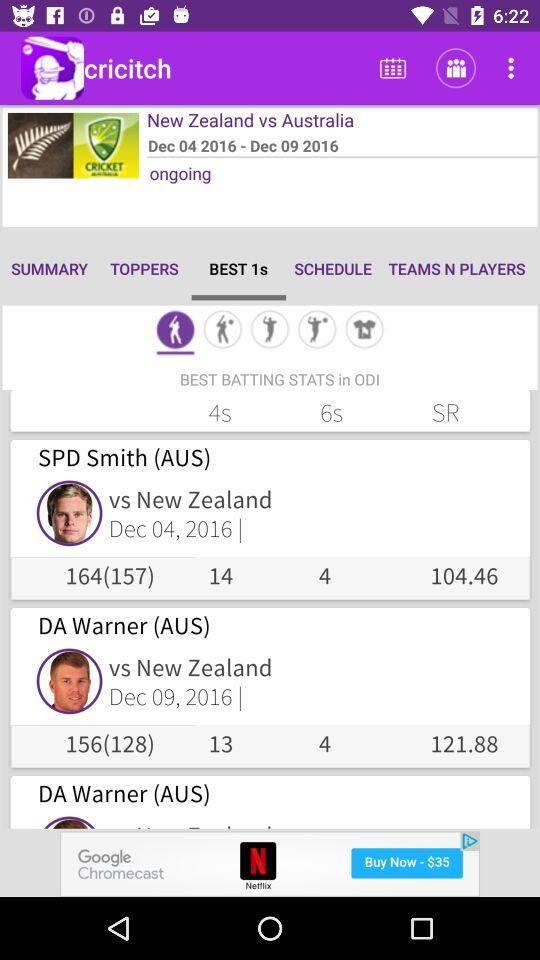What is the date range for the ongoing series? The date range for the ongoing series is from December 4, 2016 to December 9, 2016. 